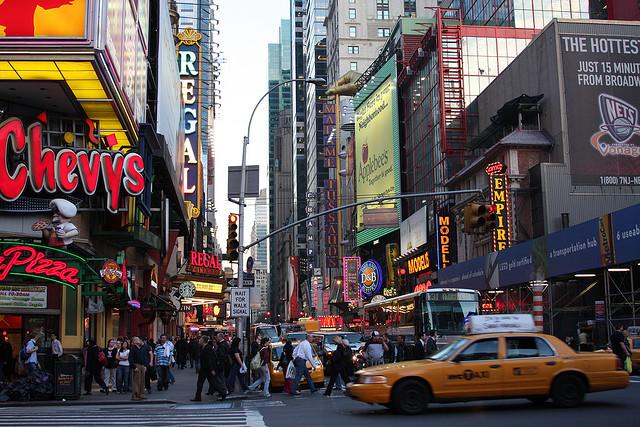How is the traffic?
Answer briefly. Busy. What common drugstore is found nearby?
Be succinct. Walgreens. Where area was the picture taken of the people and traffic?
Be succinct. City. Why are neon lights coming on?
Short answer required. Signs. 